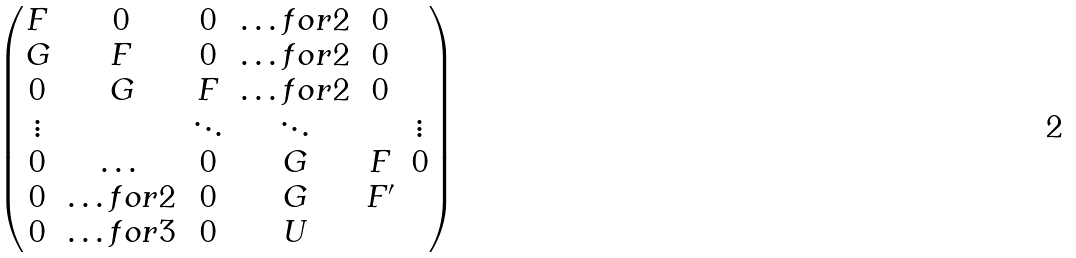<formula> <loc_0><loc_0><loc_500><loc_500>\begin{pmatrix} F & 0 & 0 & \hdots f o r 2 & 0 \\ G & F & 0 & \hdots f o r 2 & 0 \\ 0 & G & F & \hdots f o r 2 & 0 \\ \vdots & & \ddots & \ddots & & \vdots \\ 0 & \dots & 0 & G & F & 0 \\ 0 & \hdots f o r 2 & 0 & G & F ^ { \prime } \\ 0 & \hdots f o r 3 & 0 & U \\ \end{pmatrix}</formula> 